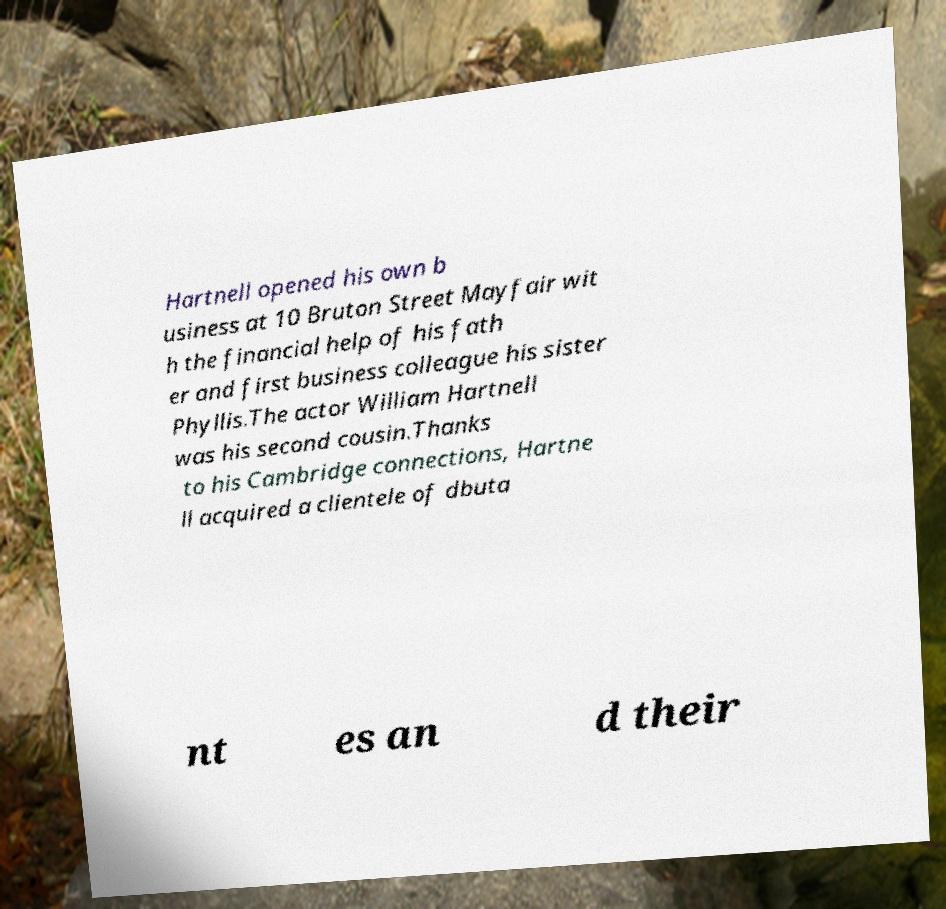Could you assist in decoding the text presented in this image and type it out clearly? Hartnell opened his own b usiness at 10 Bruton Street Mayfair wit h the financial help of his fath er and first business colleague his sister Phyllis.The actor William Hartnell was his second cousin.Thanks to his Cambridge connections, Hartne ll acquired a clientele of dbuta nt es an d their 